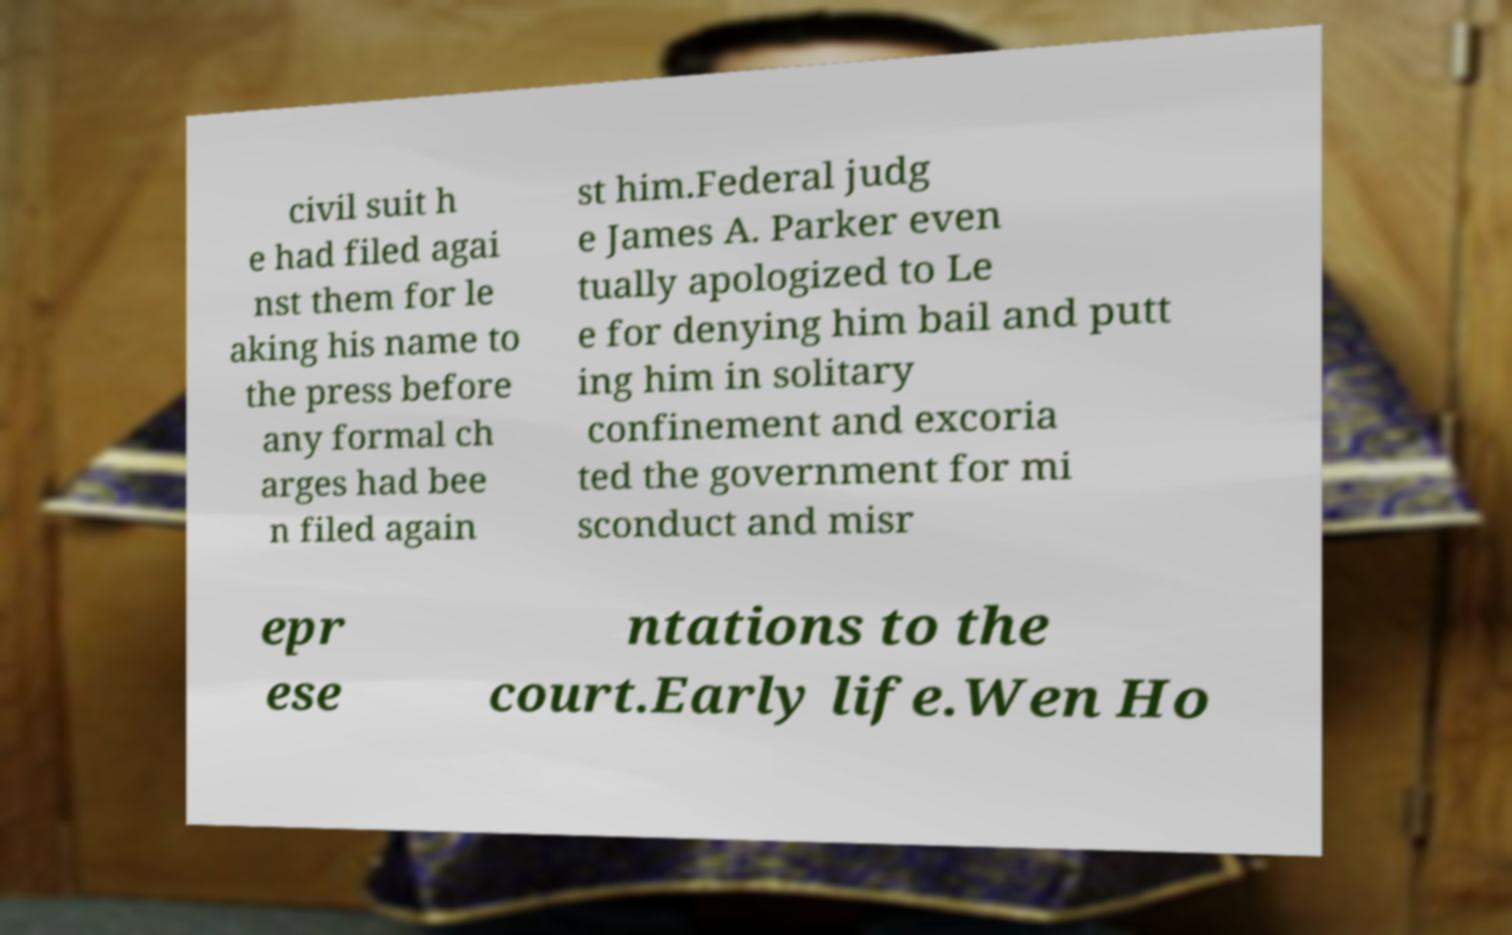Can you accurately transcribe the text from the provided image for me? civil suit h e had filed agai nst them for le aking his name to the press before any formal ch arges had bee n filed again st him.Federal judg e James A. Parker even tually apologized to Le e for denying him bail and putt ing him in solitary confinement and excoria ted the government for mi sconduct and misr epr ese ntations to the court.Early life.Wen Ho 